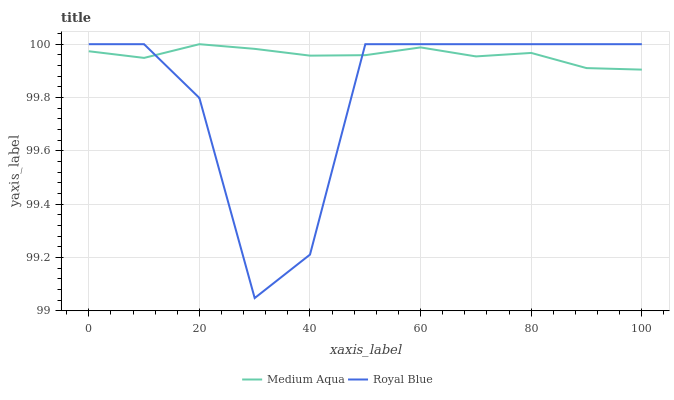Does Medium Aqua have the minimum area under the curve?
Answer yes or no. No. Is Medium Aqua the roughest?
Answer yes or no. No. Does Medium Aqua have the lowest value?
Answer yes or no. No. 